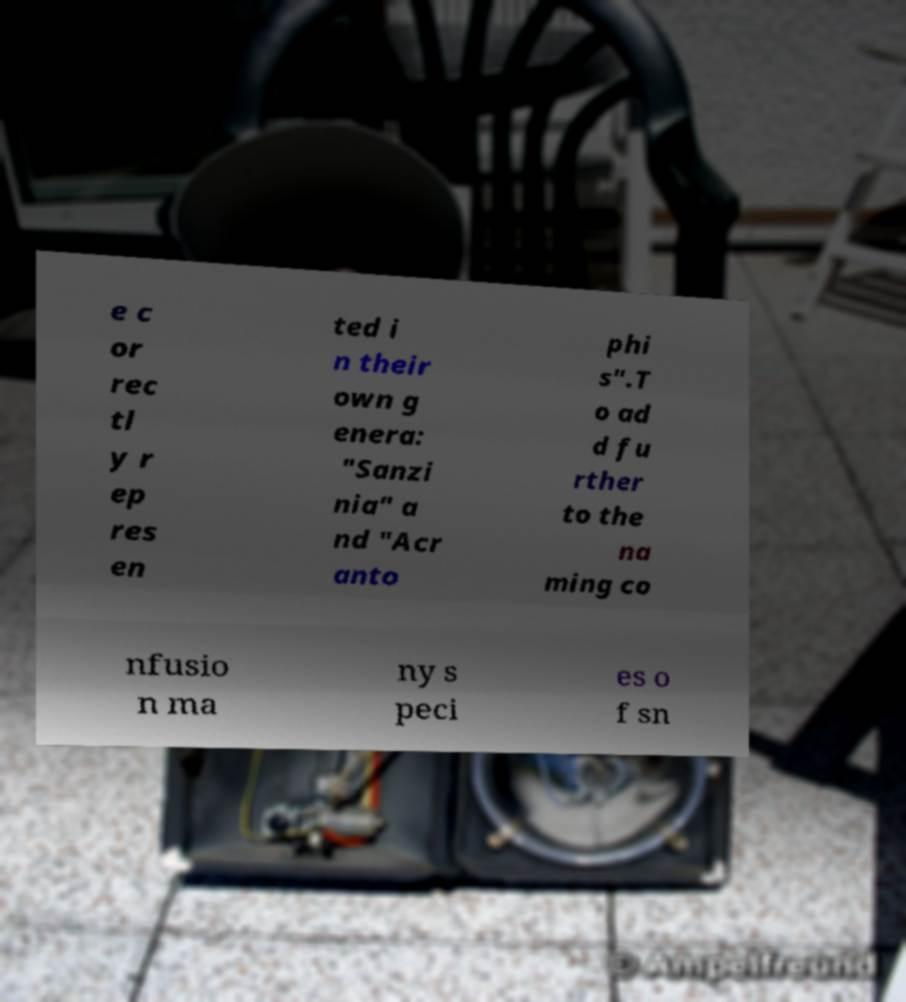For documentation purposes, I need the text within this image transcribed. Could you provide that? e c or rec tl y r ep res en ted i n their own g enera: "Sanzi nia" a nd "Acr anto phi s".T o ad d fu rther to the na ming co nfusio n ma ny s peci es o f sn 